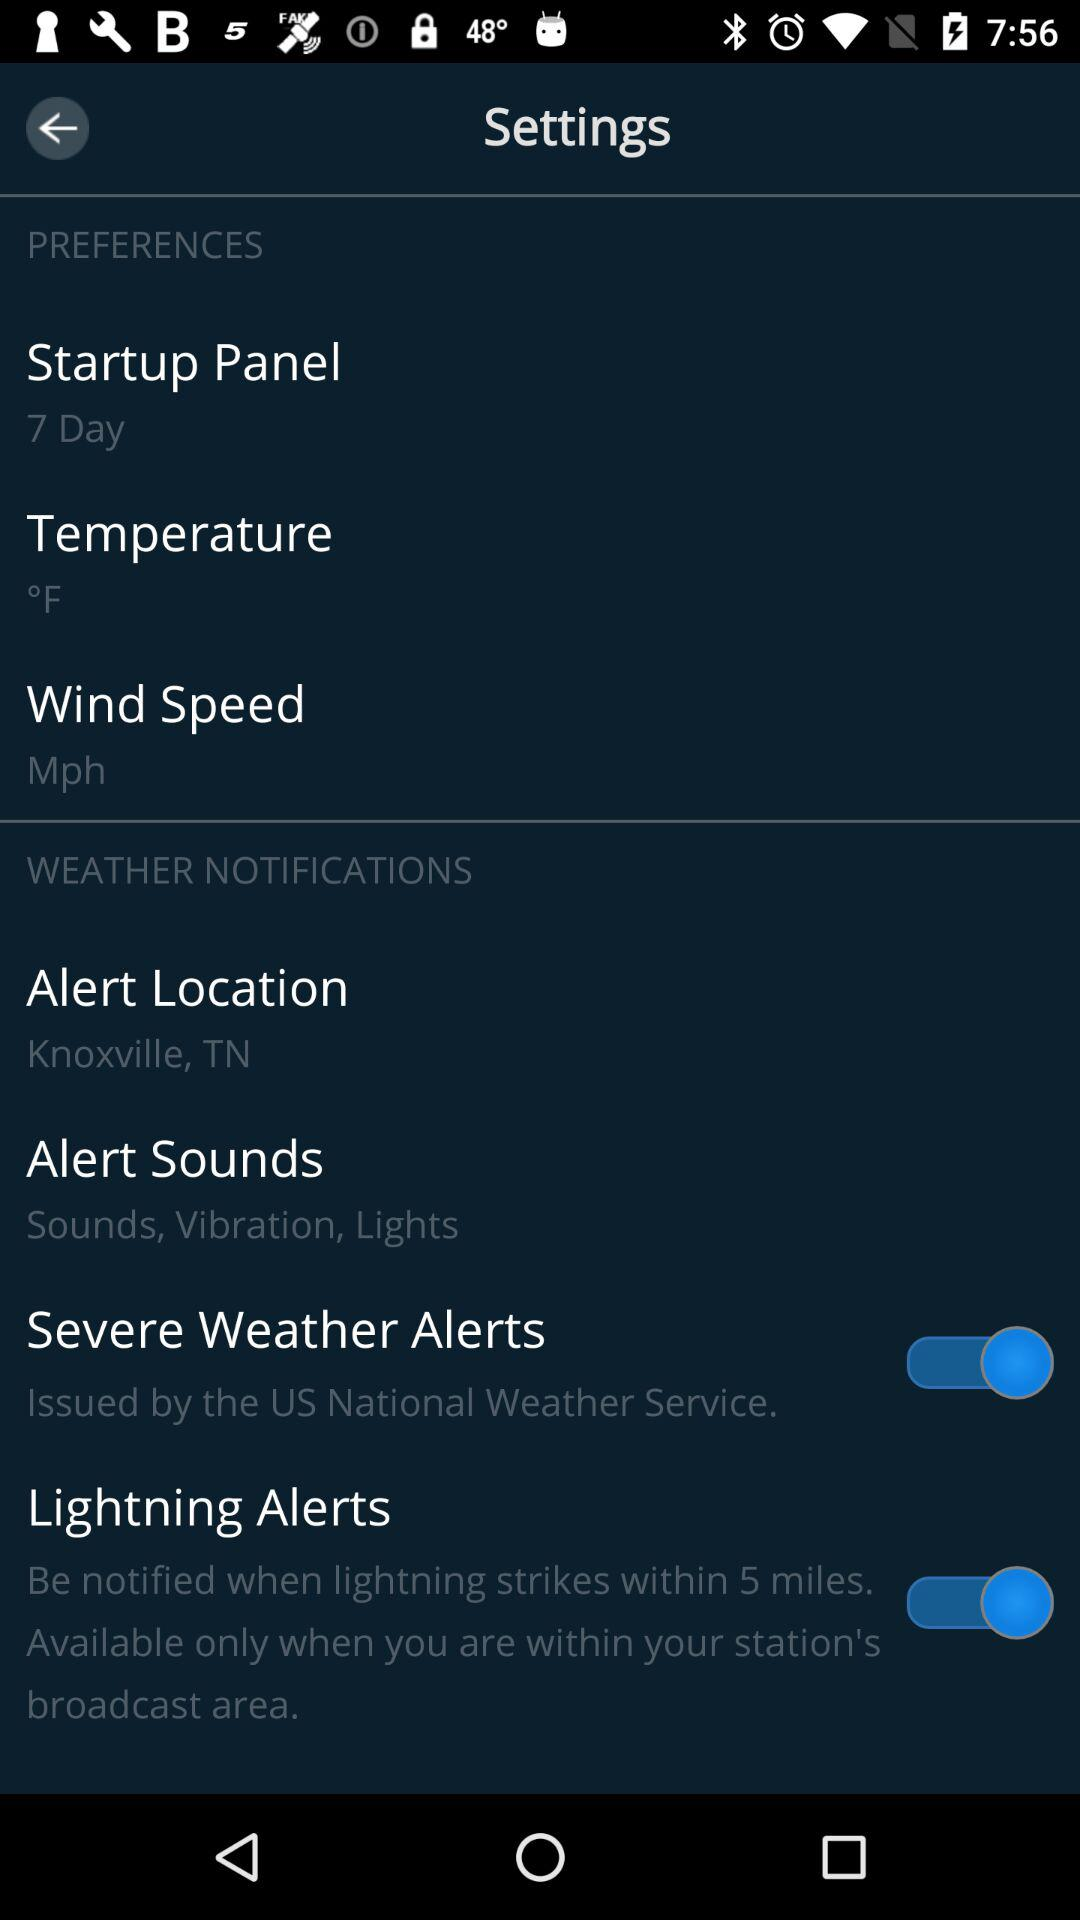What is the measuring unit of "Wind Speed"? The measuring unit is Mph. 